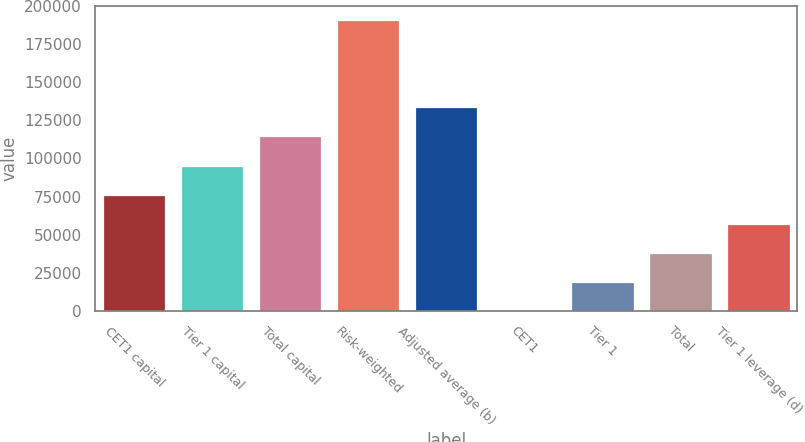Convert chart. <chart><loc_0><loc_0><loc_500><loc_500><bar_chart><fcel>CET1 capital<fcel>Tier 1 capital<fcel>Total capital<fcel>Risk-weighted<fcel>Adjusted average (b)<fcel>CET1<fcel>Tier 1<fcel>Total<fcel>Tier 1 leverage (d)<nl><fcel>76216<fcel>95267.1<fcel>114318<fcel>190523<fcel>133369<fcel>11.3<fcel>19062.5<fcel>38113.6<fcel>57164.8<nl></chart> 